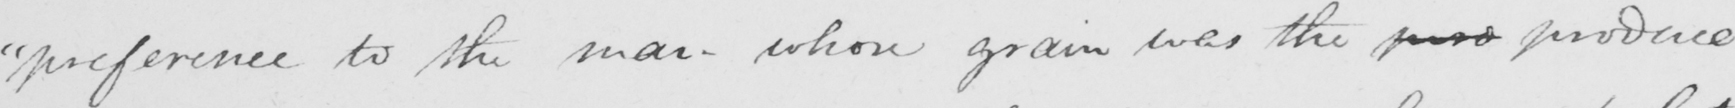Transcribe the text shown in this historical manuscript line. " preference to the man whose grain was the pro produce 